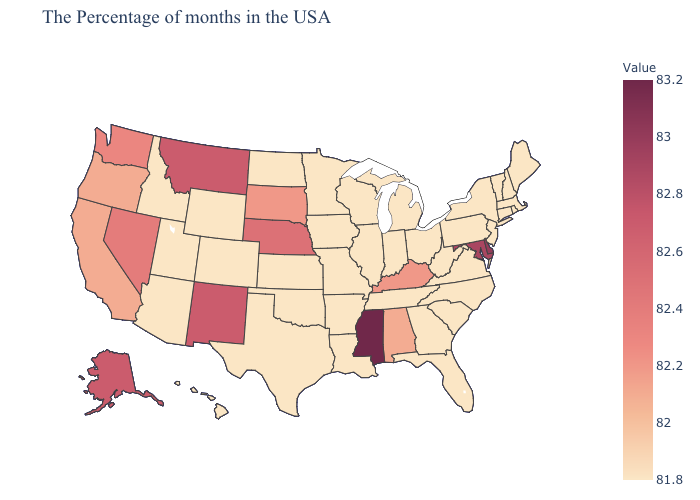Is the legend a continuous bar?
Write a very short answer. Yes. Does Texas have the lowest value in the USA?
Write a very short answer. Yes. Does Mississippi have the highest value in the USA?
Answer briefly. Yes. Does Mississippi have the highest value in the USA?
Be succinct. Yes. Among the states that border Idaho , which have the highest value?
Short answer required. Montana. Among the states that border Iowa , which have the lowest value?
Write a very short answer. Wisconsin, Illinois, Missouri, Minnesota. Does Oregon have a higher value than Maryland?
Concise answer only. No. Does Nebraska have the highest value in the MidWest?
Write a very short answer. Yes. 